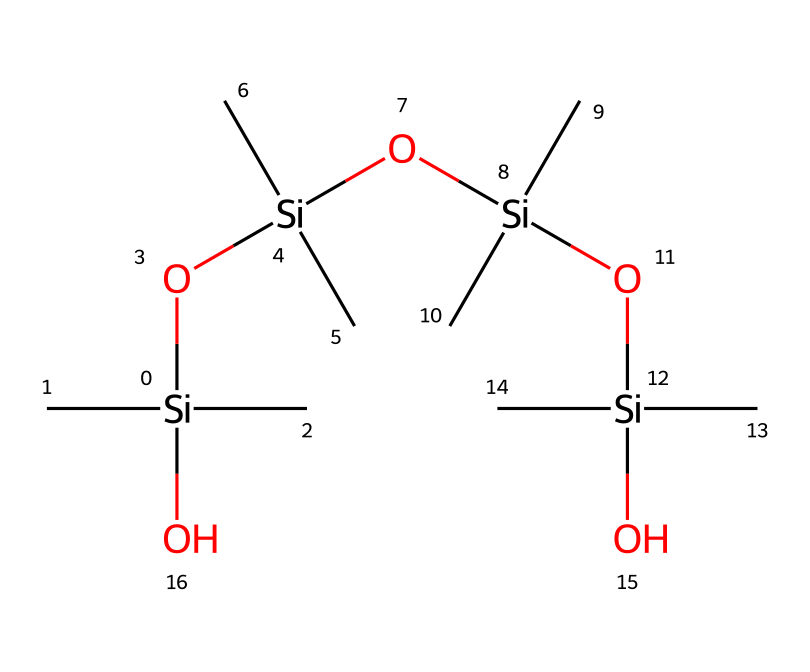what is the backbone element in this chemical structure? The chemical contains silicon atoms, which are the central backbone elements in organosilicon compounds.
Answer: silicon how many silicon atoms are present? By examining the structure, we see that there are four silicon atoms within the repeated units and the backbone of the molecule.
Answer: four what type of functional groups are present in this compound? The presence of hydroxyl (OH) groups connected to the silicon atoms points to the functional group present in this compound.
Answer: hydroxyl how many oxygen atoms are there? Counting the oxygen atoms in the structure, including the ones connecting to hydroxyl groups, we find a total of four oxygen atoms.
Answer: four what makes this organosilicon compound suitable for extreme weather conditions? The polymeric nature and flexible structure of this compound, along with its high thermal stability, contribute to its performance in extreme environmental conditions.
Answer: flexible structure what is the degree of branching in this chemical structure? The presence of multiple alkyl groups (the carbon chains) connected to each silicon atom suggests a highly branched structure.
Answer: highly branched 